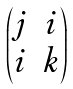<formula> <loc_0><loc_0><loc_500><loc_500>\begin{pmatrix} j & i \\ i & k \end{pmatrix}</formula> 